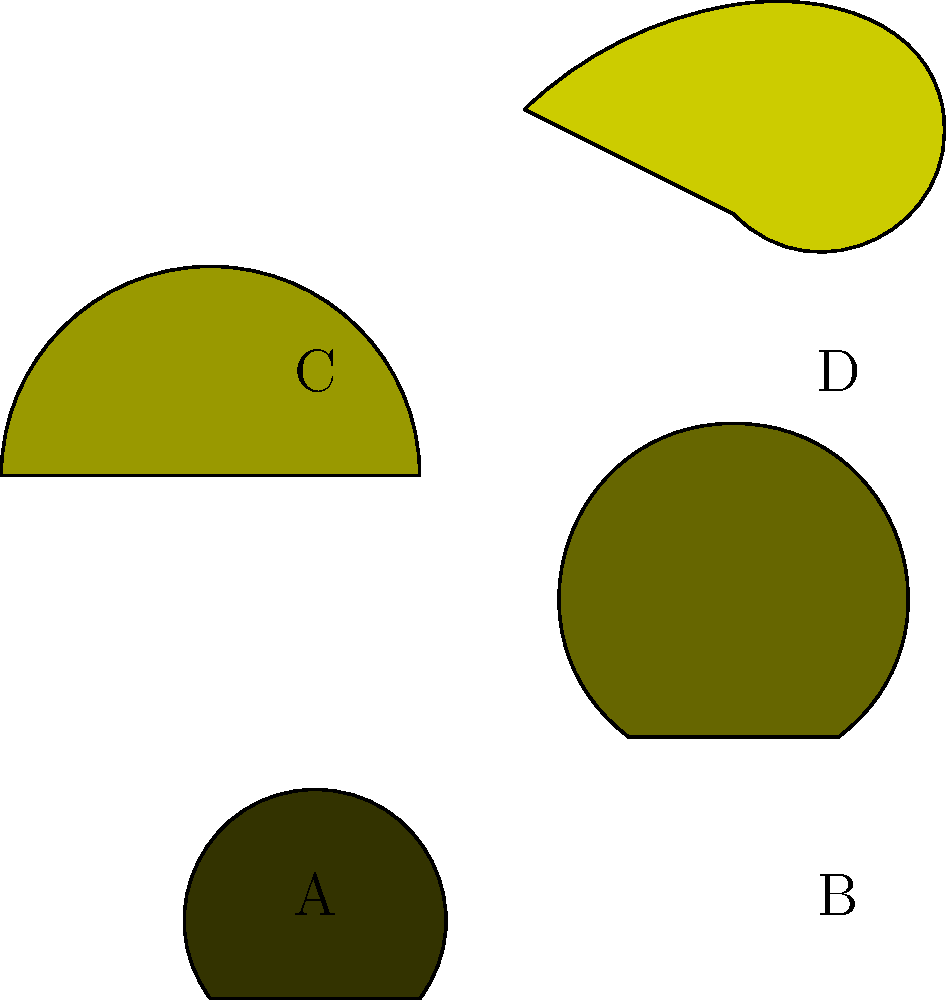In a machine learning model for classifying plant species based on leaf images, which feature extraction technique would be most effective for distinguishing between the leaf shapes shown above, particularly for species A and C? To determine the most effective feature extraction technique for distinguishing between leaf shapes, especially for species A and C, we need to consider the following steps:

1. Analyze the leaf shapes:
   - Species A has a simple, symmetrical, ovate shape
   - Species C has a more elongated, lanceolate shape

2. Consider key differences:
   - The aspect ratio (length to width ratio) is significantly different
   - The curvature of the leaf edges varies between the two species

3. Evaluate potential feature extraction techniques:
   a) Aspect ratio: This would effectively capture the difference in overall shape
   b) Edge detection: This could highlight the different curvatures but might not be as distinctive
   c) Fourier descriptors: These can capture the overall shape and edge variations but may be complex
   d) Hu moments: These are invariant to scale, rotation, and translation, which is useful for leaf classification

4. Select the most appropriate technique:
   Given the clear difference in aspect ratios between species A and C, and its simplicity to implement, the aspect ratio would be the most effective and efficient feature for this particular classification task.

5. Consider the permaculture context:
   In permaculture design, quick and efficient plant identification is crucial. The aspect ratio provides a simple yet powerful method that aligns well with permaculture principles of observation and pattern recognition.
Answer: Aspect ratio 